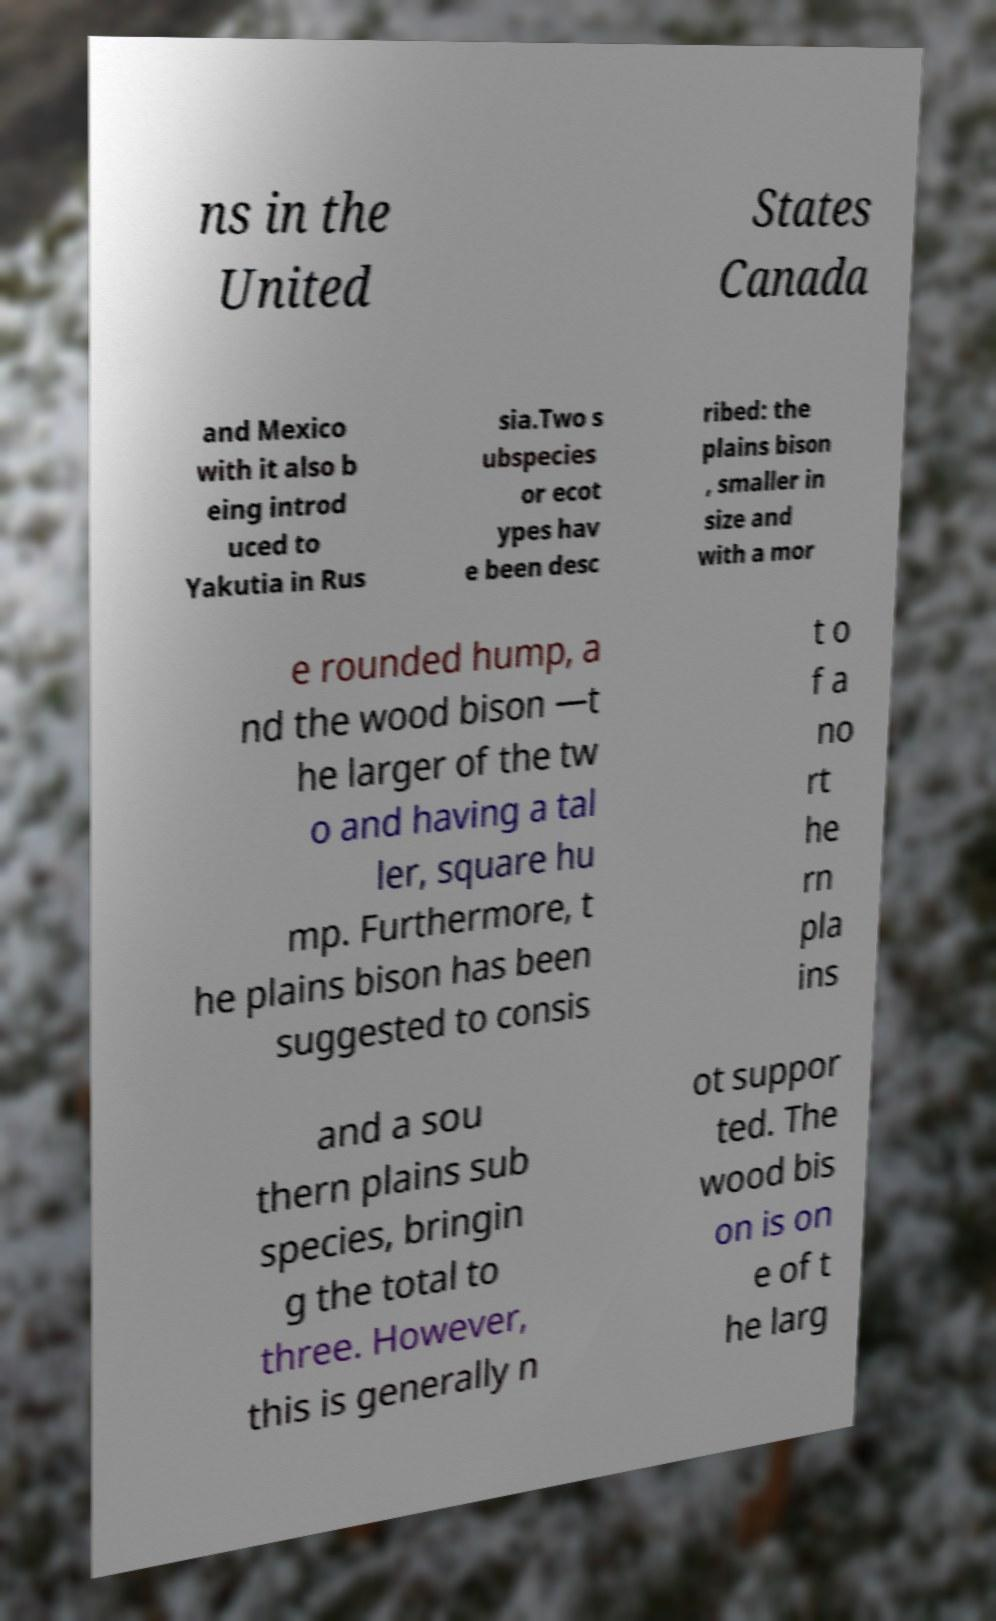I need the written content from this picture converted into text. Can you do that? ns in the United States Canada and Mexico with it also b eing introd uced to Yakutia in Rus sia.Two s ubspecies or ecot ypes hav e been desc ribed: the plains bison , smaller in size and with a mor e rounded hump, a nd the wood bison —t he larger of the tw o and having a tal ler, square hu mp. Furthermore, t he plains bison has been suggested to consis t o f a no rt he rn pla ins and a sou thern plains sub species, bringin g the total to three. However, this is generally n ot suppor ted. The wood bis on is on e of t he larg 